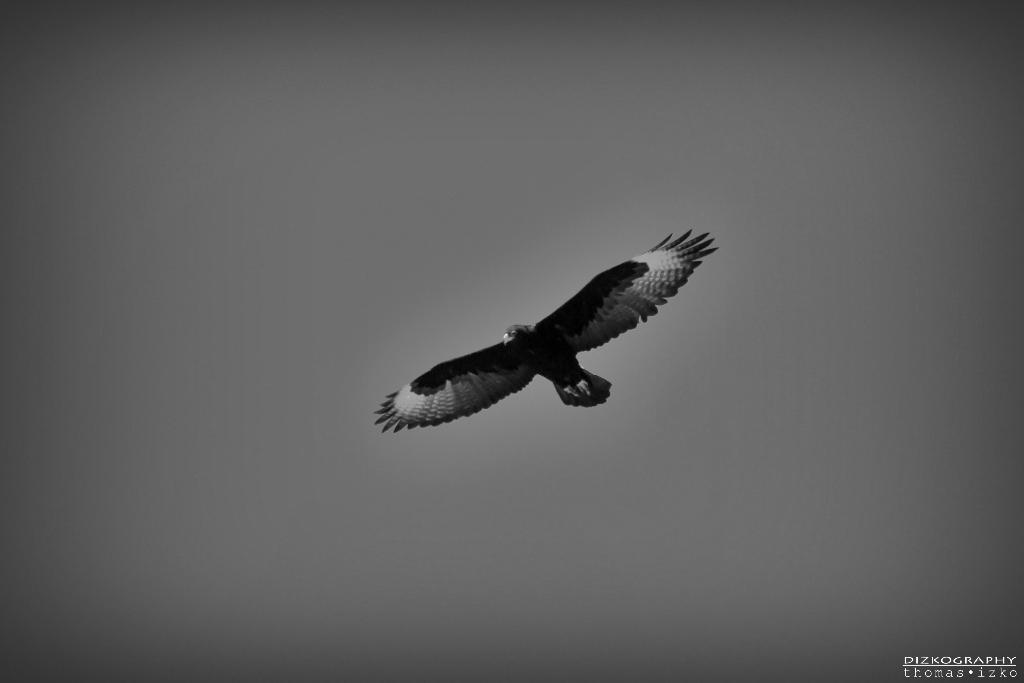What is the color scheme of the image? The image is black and white. What can be seen in the foreground of the image? There is a bird in the foreground of the image. Where is the text located in the image? The text is in the bottom right side of the image. What type of story is being told by the flame in the image? There is no flame present in the image, so no story can be told by it. 